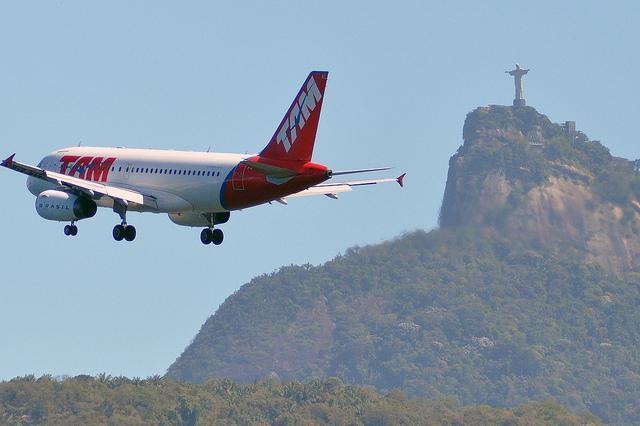How many parts is the apple cut into?
Give a very brief answer. 0. 